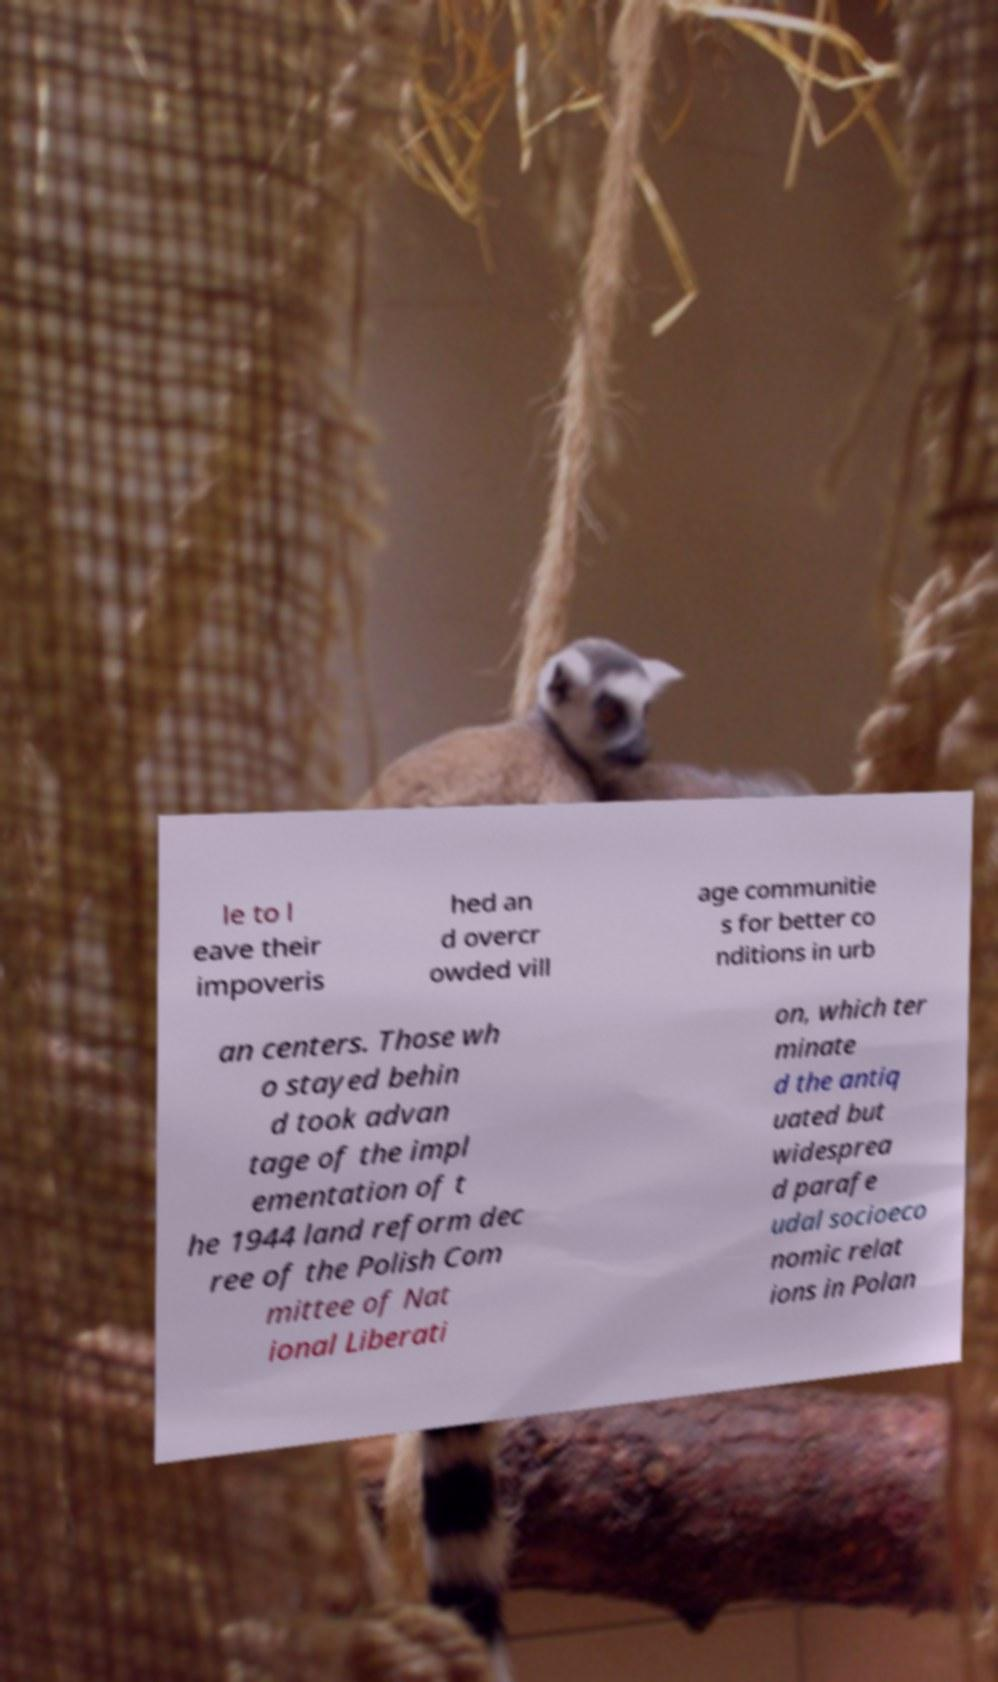For documentation purposes, I need the text within this image transcribed. Could you provide that? le to l eave their impoveris hed an d overcr owded vill age communitie s for better co nditions in urb an centers. Those wh o stayed behin d took advan tage of the impl ementation of t he 1944 land reform dec ree of the Polish Com mittee of Nat ional Liberati on, which ter minate d the antiq uated but widesprea d parafe udal socioeco nomic relat ions in Polan 